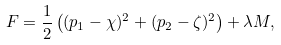Convert formula to latex. <formula><loc_0><loc_0><loc_500><loc_500>F = \frac { 1 } { 2 } \left ( ( p _ { 1 } - \chi ) ^ { 2 } + ( p _ { 2 } - \zeta ) ^ { 2 } \right ) + \lambda M ,</formula> 